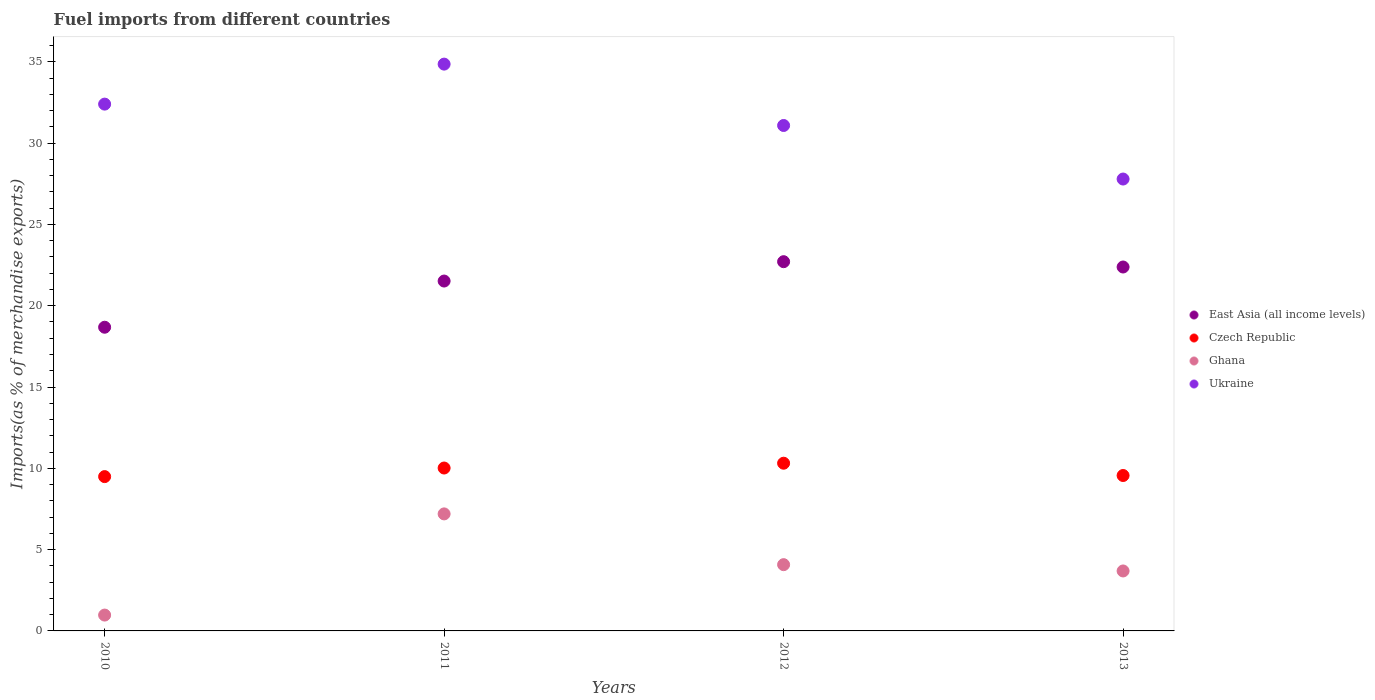What is the percentage of imports to different countries in East Asia (all income levels) in 2011?
Offer a very short reply. 21.52. Across all years, what is the maximum percentage of imports to different countries in Czech Republic?
Give a very brief answer. 10.31. Across all years, what is the minimum percentage of imports to different countries in East Asia (all income levels)?
Your answer should be compact. 18.68. In which year was the percentage of imports to different countries in Ukraine maximum?
Provide a succinct answer. 2011. In which year was the percentage of imports to different countries in Ukraine minimum?
Offer a very short reply. 2013. What is the total percentage of imports to different countries in Ghana in the graph?
Give a very brief answer. 15.93. What is the difference between the percentage of imports to different countries in Czech Republic in 2010 and that in 2012?
Give a very brief answer. -0.82. What is the difference between the percentage of imports to different countries in Czech Republic in 2013 and the percentage of imports to different countries in Ghana in 2012?
Ensure brevity in your answer.  5.48. What is the average percentage of imports to different countries in Ghana per year?
Your answer should be very brief. 3.98. In the year 2013, what is the difference between the percentage of imports to different countries in Czech Republic and percentage of imports to different countries in Ukraine?
Your answer should be very brief. -18.23. What is the ratio of the percentage of imports to different countries in Czech Republic in 2012 to that in 2013?
Ensure brevity in your answer.  1.08. Is the percentage of imports to different countries in Ukraine in 2011 less than that in 2012?
Your answer should be compact. No. What is the difference between the highest and the second highest percentage of imports to different countries in East Asia (all income levels)?
Make the answer very short. 0.33. What is the difference between the highest and the lowest percentage of imports to different countries in Ukraine?
Your response must be concise. 7.07. Is the sum of the percentage of imports to different countries in Ukraine in 2012 and 2013 greater than the maximum percentage of imports to different countries in Ghana across all years?
Provide a short and direct response. Yes. Does the percentage of imports to different countries in Ukraine monotonically increase over the years?
Keep it short and to the point. No. How many years are there in the graph?
Make the answer very short. 4. What is the difference between two consecutive major ticks on the Y-axis?
Ensure brevity in your answer.  5. Does the graph contain any zero values?
Give a very brief answer. No. Does the graph contain grids?
Give a very brief answer. No. What is the title of the graph?
Offer a terse response. Fuel imports from different countries. What is the label or title of the Y-axis?
Provide a succinct answer. Imports(as % of merchandise exports). What is the Imports(as % of merchandise exports) in East Asia (all income levels) in 2010?
Your response must be concise. 18.68. What is the Imports(as % of merchandise exports) in Czech Republic in 2010?
Your answer should be very brief. 9.49. What is the Imports(as % of merchandise exports) of Ghana in 2010?
Ensure brevity in your answer.  0.97. What is the Imports(as % of merchandise exports) of Ukraine in 2010?
Keep it short and to the point. 32.4. What is the Imports(as % of merchandise exports) of East Asia (all income levels) in 2011?
Ensure brevity in your answer.  21.52. What is the Imports(as % of merchandise exports) in Czech Republic in 2011?
Offer a terse response. 10.02. What is the Imports(as % of merchandise exports) of Ghana in 2011?
Offer a very short reply. 7.2. What is the Imports(as % of merchandise exports) in Ukraine in 2011?
Your response must be concise. 34.86. What is the Imports(as % of merchandise exports) in East Asia (all income levels) in 2012?
Keep it short and to the point. 22.71. What is the Imports(as % of merchandise exports) in Czech Republic in 2012?
Give a very brief answer. 10.31. What is the Imports(as % of merchandise exports) of Ghana in 2012?
Make the answer very short. 4.07. What is the Imports(as % of merchandise exports) of Ukraine in 2012?
Give a very brief answer. 31.08. What is the Imports(as % of merchandise exports) in East Asia (all income levels) in 2013?
Offer a very short reply. 22.38. What is the Imports(as % of merchandise exports) of Czech Republic in 2013?
Offer a very short reply. 9.56. What is the Imports(as % of merchandise exports) of Ghana in 2013?
Provide a short and direct response. 3.69. What is the Imports(as % of merchandise exports) of Ukraine in 2013?
Your answer should be very brief. 27.79. Across all years, what is the maximum Imports(as % of merchandise exports) in East Asia (all income levels)?
Make the answer very short. 22.71. Across all years, what is the maximum Imports(as % of merchandise exports) in Czech Republic?
Provide a succinct answer. 10.31. Across all years, what is the maximum Imports(as % of merchandise exports) in Ghana?
Keep it short and to the point. 7.2. Across all years, what is the maximum Imports(as % of merchandise exports) of Ukraine?
Offer a very short reply. 34.86. Across all years, what is the minimum Imports(as % of merchandise exports) in East Asia (all income levels)?
Your answer should be compact. 18.68. Across all years, what is the minimum Imports(as % of merchandise exports) in Czech Republic?
Provide a succinct answer. 9.49. Across all years, what is the minimum Imports(as % of merchandise exports) in Ghana?
Provide a short and direct response. 0.97. Across all years, what is the minimum Imports(as % of merchandise exports) in Ukraine?
Make the answer very short. 27.79. What is the total Imports(as % of merchandise exports) in East Asia (all income levels) in the graph?
Your response must be concise. 85.28. What is the total Imports(as % of merchandise exports) of Czech Republic in the graph?
Your response must be concise. 39.38. What is the total Imports(as % of merchandise exports) in Ghana in the graph?
Provide a short and direct response. 15.93. What is the total Imports(as % of merchandise exports) in Ukraine in the graph?
Keep it short and to the point. 126.13. What is the difference between the Imports(as % of merchandise exports) of East Asia (all income levels) in 2010 and that in 2011?
Provide a succinct answer. -2.84. What is the difference between the Imports(as % of merchandise exports) in Czech Republic in 2010 and that in 2011?
Your answer should be compact. -0.53. What is the difference between the Imports(as % of merchandise exports) of Ghana in 2010 and that in 2011?
Your answer should be very brief. -6.22. What is the difference between the Imports(as % of merchandise exports) of Ukraine in 2010 and that in 2011?
Offer a terse response. -2.46. What is the difference between the Imports(as % of merchandise exports) in East Asia (all income levels) in 2010 and that in 2012?
Offer a terse response. -4.03. What is the difference between the Imports(as % of merchandise exports) of Czech Republic in 2010 and that in 2012?
Offer a terse response. -0.82. What is the difference between the Imports(as % of merchandise exports) of Ghana in 2010 and that in 2012?
Make the answer very short. -3.1. What is the difference between the Imports(as % of merchandise exports) of Ukraine in 2010 and that in 2012?
Offer a terse response. 1.31. What is the difference between the Imports(as % of merchandise exports) of East Asia (all income levels) in 2010 and that in 2013?
Your answer should be very brief. -3.7. What is the difference between the Imports(as % of merchandise exports) of Czech Republic in 2010 and that in 2013?
Offer a very short reply. -0.07. What is the difference between the Imports(as % of merchandise exports) in Ghana in 2010 and that in 2013?
Provide a short and direct response. -2.71. What is the difference between the Imports(as % of merchandise exports) in Ukraine in 2010 and that in 2013?
Make the answer very short. 4.61. What is the difference between the Imports(as % of merchandise exports) of East Asia (all income levels) in 2011 and that in 2012?
Your response must be concise. -1.19. What is the difference between the Imports(as % of merchandise exports) in Czech Republic in 2011 and that in 2012?
Your response must be concise. -0.3. What is the difference between the Imports(as % of merchandise exports) of Ghana in 2011 and that in 2012?
Ensure brevity in your answer.  3.12. What is the difference between the Imports(as % of merchandise exports) of Ukraine in 2011 and that in 2012?
Your answer should be very brief. 3.77. What is the difference between the Imports(as % of merchandise exports) of East Asia (all income levels) in 2011 and that in 2013?
Make the answer very short. -0.86. What is the difference between the Imports(as % of merchandise exports) in Czech Republic in 2011 and that in 2013?
Provide a succinct answer. 0.46. What is the difference between the Imports(as % of merchandise exports) of Ghana in 2011 and that in 2013?
Offer a very short reply. 3.51. What is the difference between the Imports(as % of merchandise exports) in Ukraine in 2011 and that in 2013?
Provide a short and direct response. 7.07. What is the difference between the Imports(as % of merchandise exports) in East Asia (all income levels) in 2012 and that in 2013?
Ensure brevity in your answer.  0.33. What is the difference between the Imports(as % of merchandise exports) of Czech Republic in 2012 and that in 2013?
Make the answer very short. 0.76. What is the difference between the Imports(as % of merchandise exports) in Ghana in 2012 and that in 2013?
Ensure brevity in your answer.  0.39. What is the difference between the Imports(as % of merchandise exports) in Ukraine in 2012 and that in 2013?
Your answer should be very brief. 3.29. What is the difference between the Imports(as % of merchandise exports) in East Asia (all income levels) in 2010 and the Imports(as % of merchandise exports) in Czech Republic in 2011?
Your answer should be very brief. 8.66. What is the difference between the Imports(as % of merchandise exports) in East Asia (all income levels) in 2010 and the Imports(as % of merchandise exports) in Ghana in 2011?
Ensure brevity in your answer.  11.48. What is the difference between the Imports(as % of merchandise exports) of East Asia (all income levels) in 2010 and the Imports(as % of merchandise exports) of Ukraine in 2011?
Provide a succinct answer. -16.18. What is the difference between the Imports(as % of merchandise exports) of Czech Republic in 2010 and the Imports(as % of merchandise exports) of Ghana in 2011?
Provide a short and direct response. 2.29. What is the difference between the Imports(as % of merchandise exports) of Czech Republic in 2010 and the Imports(as % of merchandise exports) of Ukraine in 2011?
Keep it short and to the point. -25.37. What is the difference between the Imports(as % of merchandise exports) in Ghana in 2010 and the Imports(as % of merchandise exports) in Ukraine in 2011?
Offer a very short reply. -33.88. What is the difference between the Imports(as % of merchandise exports) of East Asia (all income levels) in 2010 and the Imports(as % of merchandise exports) of Czech Republic in 2012?
Your response must be concise. 8.36. What is the difference between the Imports(as % of merchandise exports) in East Asia (all income levels) in 2010 and the Imports(as % of merchandise exports) in Ghana in 2012?
Offer a very short reply. 14.6. What is the difference between the Imports(as % of merchandise exports) of East Asia (all income levels) in 2010 and the Imports(as % of merchandise exports) of Ukraine in 2012?
Your answer should be very brief. -12.41. What is the difference between the Imports(as % of merchandise exports) in Czech Republic in 2010 and the Imports(as % of merchandise exports) in Ghana in 2012?
Keep it short and to the point. 5.42. What is the difference between the Imports(as % of merchandise exports) in Czech Republic in 2010 and the Imports(as % of merchandise exports) in Ukraine in 2012?
Offer a very short reply. -21.59. What is the difference between the Imports(as % of merchandise exports) in Ghana in 2010 and the Imports(as % of merchandise exports) in Ukraine in 2012?
Your response must be concise. -30.11. What is the difference between the Imports(as % of merchandise exports) of East Asia (all income levels) in 2010 and the Imports(as % of merchandise exports) of Czech Republic in 2013?
Make the answer very short. 9.12. What is the difference between the Imports(as % of merchandise exports) in East Asia (all income levels) in 2010 and the Imports(as % of merchandise exports) in Ghana in 2013?
Your answer should be compact. 14.99. What is the difference between the Imports(as % of merchandise exports) of East Asia (all income levels) in 2010 and the Imports(as % of merchandise exports) of Ukraine in 2013?
Your answer should be very brief. -9.11. What is the difference between the Imports(as % of merchandise exports) of Czech Republic in 2010 and the Imports(as % of merchandise exports) of Ghana in 2013?
Your response must be concise. 5.8. What is the difference between the Imports(as % of merchandise exports) in Czech Republic in 2010 and the Imports(as % of merchandise exports) in Ukraine in 2013?
Offer a terse response. -18.3. What is the difference between the Imports(as % of merchandise exports) in Ghana in 2010 and the Imports(as % of merchandise exports) in Ukraine in 2013?
Provide a succinct answer. -26.82. What is the difference between the Imports(as % of merchandise exports) of East Asia (all income levels) in 2011 and the Imports(as % of merchandise exports) of Czech Republic in 2012?
Offer a terse response. 11.2. What is the difference between the Imports(as % of merchandise exports) of East Asia (all income levels) in 2011 and the Imports(as % of merchandise exports) of Ghana in 2012?
Provide a succinct answer. 17.44. What is the difference between the Imports(as % of merchandise exports) of East Asia (all income levels) in 2011 and the Imports(as % of merchandise exports) of Ukraine in 2012?
Offer a terse response. -9.57. What is the difference between the Imports(as % of merchandise exports) of Czech Republic in 2011 and the Imports(as % of merchandise exports) of Ghana in 2012?
Keep it short and to the point. 5.94. What is the difference between the Imports(as % of merchandise exports) in Czech Republic in 2011 and the Imports(as % of merchandise exports) in Ukraine in 2012?
Keep it short and to the point. -21.06. What is the difference between the Imports(as % of merchandise exports) of Ghana in 2011 and the Imports(as % of merchandise exports) of Ukraine in 2012?
Keep it short and to the point. -23.89. What is the difference between the Imports(as % of merchandise exports) in East Asia (all income levels) in 2011 and the Imports(as % of merchandise exports) in Czech Republic in 2013?
Make the answer very short. 11.96. What is the difference between the Imports(as % of merchandise exports) in East Asia (all income levels) in 2011 and the Imports(as % of merchandise exports) in Ghana in 2013?
Keep it short and to the point. 17.83. What is the difference between the Imports(as % of merchandise exports) of East Asia (all income levels) in 2011 and the Imports(as % of merchandise exports) of Ukraine in 2013?
Your answer should be very brief. -6.27. What is the difference between the Imports(as % of merchandise exports) of Czech Republic in 2011 and the Imports(as % of merchandise exports) of Ghana in 2013?
Offer a very short reply. 6.33. What is the difference between the Imports(as % of merchandise exports) of Czech Republic in 2011 and the Imports(as % of merchandise exports) of Ukraine in 2013?
Give a very brief answer. -17.77. What is the difference between the Imports(as % of merchandise exports) of Ghana in 2011 and the Imports(as % of merchandise exports) of Ukraine in 2013?
Ensure brevity in your answer.  -20.59. What is the difference between the Imports(as % of merchandise exports) of East Asia (all income levels) in 2012 and the Imports(as % of merchandise exports) of Czech Republic in 2013?
Ensure brevity in your answer.  13.15. What is the difference between the Imports(as % of merchandise exports) of East Asia (all income levels) in 2012 and the Imports(as % of merchandise exports) of Ghana in 2013?
Offer a terse response. 19.02. What is the difference between the Imports(as % of merchandise exports) of East Asia (all income levels) in 2012 and the Imports(as % of merchandise exports) of Ukraine in 2013?
Provide a succinct answer. -5.08. What is the difference between the Imports(as % of merchandise exports) in Czech Republic in 2012 and the Imports(as % of merchandise exports) in Ghana in 2013?
Give a very brief answer. 6.63. What is the difference between the Imports(as % of merchandise exports) in Czech Republic in 2012 and the Imports(as % of merchandise exports) in Ukraine in 2013?
Your response must be concise. -17.48. What is the difference between the Imports(as % of merchandise exports) in Ghana in 2012 and the Imports(as % of merchandise exports) in Ukraine in 2013?
Make the answer very short. -23.71. What is the average Imports(as % of merchandise exports) of East Asia (all income levels) per year?
Provide a short and direct response. 21.32. What is the average Imports(as % of merchandise exports) in Czech Republic per year?
Provide a succinct answer. 9.84. What is the average Imports(as % of merchandise exports) in Ghana per year?
Provide a succinct answer. 3.98. What is the average Imports(as % of merchandise exports) in Ukraine per year?
Your answer should be very brief. 31.53. In the year 2010, what is the difference between the Imports(as % of merchandise exports) in East Asia (all income levels) and Imports(as % of merchandise exports) in Czech Republic?
Make the answer very short. 9.19. In the year 2010, what is the difference between the Imports(as % of merchandise exports) in East Asia (all income levels) and Imports(as % of merchandise exports) in Ghana?
Give a very brief answer. 17.7. In the year 2010, what is the difference between the Imports(as % of merchandise exports) of East Asia (all income levels) and Imports(as % of merchandise exports) of Ukraine?
Your answer should be very brief. -13.72. In the year 2010, what is the difference between the Imports(as % of merchandise exports) of Czech Republic and Imports(as % of merchandise exports) of Ghana?
Offer a very short reply. 8.52. In the year 2010, what is the difference between the Imports(as % of merchandise exports) of Czech Republic and Imports(as % of merchandise exports) of Ukraine?
Keep it short and to the point. -22.91. In the year 2010, what is the difference between the Imports(as % of merchandise exports) in Ghana and Imports(as % of merchandise exports) in Ukraine?
Make the answer very short. -31.42. In the year 2011, what is the difference between the Imports(as % of merchandise exports) in East Asia (all income levels) and Imports(as % of merchandise exports) in Czech Republic?
Ensure brevity in your answer.  11.5. In the year 2011, what is the difference between the Imports(as % of merchandise exports) in East Asia (all income levels) and Imports(as % of merchandise exports) in Ghana?
Offer a terse response. 14.32. In the year 2011, what is the difference between the Imports(as % of merchandise exports) of East Asia (all income levels) and Imports(as % of merchandise exports) of Ukraine?
Offer a very short reply. -13.34. In the year 2011, what is the difference between the Imports(as % of merchandise exports) of Czech Republic and Imports(as % of merchandise exports) of Ghana?
Your response must be concise. 2.82. In the year 2011, what is the difference between the Imports(as % of merchandise exports) of Czech Republic and Imports(as % of merchandise exports) of Ukraine?
Your answer should be compact. -24.84. In the year 2011, what is the difference between the Imports(as % of merchandise exports) in Ghana and Imports(as % of merchandise exports) in Ukraine?
Your answer should be compact. -27.66. In the year 2012, what is the difference between the Imports(as % of merchandise exports) of East Asia (all income levels) and Imports(as % of merchandise exports) of Czech Republic?
Keep it short and to the point. 12.39. In the year 2012, what is the difference between the Imports(as % of merchandise exports) of East Asia (all income levels) and Imports(as % of merchandise exports) of Ghana?
Keep it short and to the point. 18.63. In the year 2012, what is the difference between the Imports(as % of merchandise exports) of East Asia (all income levels) and Imports(as % of merchandise exports) of Ukraine?
Give a very brief answer. -8.38. In the year 2012, what is the difference between the Imports(as % of merchandise exports) of Czech Republic and Imports(as % of merchandise exports) of Ghana?
Ensure brevity in your answer.  6.24. In the year 2012, what is the difference between the Imports(as % of merchandise exports) of Czech Republic and Imports(as % of merchandise exports) of Ukraine?
Ensure brevity in your answer.  -20.77. In the year 2012, what is the difference between the Imports(as % of merchandise exports) in Ghana and Imports(as % of merchandise exports) in Ukraine?
Make the answer very short. -27.01. In the year 2013, what is the difference between the Imports(as % of merchandise exports) in East Asia (all income levels) and Imports(as % of merchandise exports) in Czech Republic?
Provide a short and direct response. 12.82. In the year 2013, what is the difference between the Imports(as % of merchandise exports) of East Asia (all income levels) and Imports(as % of merchandise exports) of Ghana?
Provide a succinct answer. 18.69. In the year 2013, what is the difference between the Imports(as % of merchandise exports) of East Asia (all income levels) and Imports(as % of merchandise exports) of Ukraine?
Provide a succinct answer. -5.41. In the year 2013, what is the difference between the Imports(as % of merchandise exports) of Czech Republic and Imports(as % of merchandise exports) of Ghana?
Your answer should be very brief. 5.87. In the year 2013, what is the difference between the Imports(as % of merchandise exports) of Czech Republic and Imports(as % of merchandise exports) of Ukraine?
Your answer should be very brief. -18.23. In the year 2013, what is the difference between the Imports(as % of merchandise exports) of Ghana and Imports(as % of merchandise exports) of Ukraine?
Your answer should be compact. -24.1. What is the ratio of the Imports(as % of merchandise exports) in East Asia (all income levels) in 2010 to that in 2011?
Make the answer very short. 0.87. What is the ratio of the Imports(as % of merchandise exports) of Czech Republic in 2010 to that in 2011?
Provide a short and direct response. 0.95. What is the ratio of the Imports(as % of merchandise exports) in Ghana in 2010 to that in 2011?
Give a very brief answer. 0.14. What is the ratio of the Imports(as % of merchandise exports) of Ukraine in 2010 to that in 2011?
Provide a short and direct response. 0.93. What is the ratio of the Imports(as % of merchandise exports) in East Asia (all income levels) in 2010 to that in 2012?
Keep it short and to the point. 0.82. What is the ratio of the Imports(as % of merchandise exports) of Czech Republic in 2010 to that in 2012?
Make the answer very short. 0.92. What is the ratio of the Imports(as % of merchandise exports) of Ghana in 2010 to that in 2012?
Your answer should be very brief. 0.24. What is the ratio of the Imports(as % of merchandise exports) of Ukraine in 2010 to that in 2012?
Keep it short and to the point. 1.04. What is the ratio of the Imports(as % of merchandise exports) in East Asia (all income levels) in 2010 to that in 2013?
Your answer should be compact. 0.83. What is the ratio of the Imports(as % of merchandise exports) of Ghana in 2010 to that in 2013?
Your answer should be compact. 0.26. What is the ratio of the Imports(as % of merchandise exports) in Ukraine in 2010 to that in 2013?
Keep it short and to the point. 1.17. What is the ratio of the Imports(as % of merchandise exports) of East Asia (all income levels) in 2011 to that in 2012?
Keep it short and to the point. 0.95. What is the ratio of the Imports(as % of merchandise exports) of Czech Republic in 2011 to that in 2012?
Offer a terse response. 0.97. What is the ratio of the Imports(as % of merchandise exports) in Ghana in 2011 to that in 2012?
Give a very brief answer. 1.77. What is the ratio of the Imports(as % of merchandise exports) of Ukraine in 2011 to that in 2012?
Your answer should be very brief. 1.12. What is the ratio of the Imports(as % of merchandise exports) in East Asia (all income levels) in 2011 to that in 2013?
Your answer should be very brief. 0.96. What is the ratio of the Imports(as % of merchandise exports) of Czech Republic in 2011 to that in 2013?
Your response must be concise. 1.05. What is the ratio of the Imports(as % of merchandise exports) in Ghana in 2011 to that in 2013?
Offer a terse response. 1.95. What is the ratio of the Imports(as % of merchandise exports) in Ukraine in 2011 to that in 2013?
Make the answer very short. 1.25. What is the ratio of the Imports(as % of merchandise exports) in East Asia (all income levels) in 2012 to that in 2013?
Offer a very short reply. 1.01. What is the ratio of the Imports(as % of merchandise exports) in Czech Republic in 2012 to that in 2013?
Ensure brevity in your answer.  1.08. What is the ratio of the Imports(as % of merchandise exports) of Ghana in 2012 to that in 2013?
Offer a very short reply. 1.11. What is the ratio of the Imports(as % of merchandise exports) of Ukraine in 2012 to that in 2013?
Keep it short and to the point. 1.12. What is the difference between the highest and the second highest Imports(as % of merchandise exports) of East Asia (all income levels)?
Your answer should be very brief. 0.33. What is the difference between the highest and the second highest Imports(as % of merchandise exports) in Czech Republic?
Ensure brevity in your answer.  0.3. What is the difference between the highest and the second highest Imports(as % of merchandise exports) of Ghana?
Your answer should be very brief. 3.12. What is the difference between the highest and the second highest Imports(as % of merchandise exports) of Ukraine?
Keep it short and to the point. 2.46. What is the difference between the highest and the lowest Imports(as % of merchandise exports) of East Asia (all income levels)?
Your answer should be compact. 4.03. What is the difference between the highest and the lowest Imports(as % of merchandise exports) of Czech Republic?
Provide a succinct answer. 0.82. What is the difference between the highest and the lowest Imports(as % of merchandise exports) of Ghana?
Offer a terse response. 6.22. What is the difference between the highest and the lowest Imports(as % of merchandise exports) in Ukraine?
Keep it short and to the point. 7.07. 